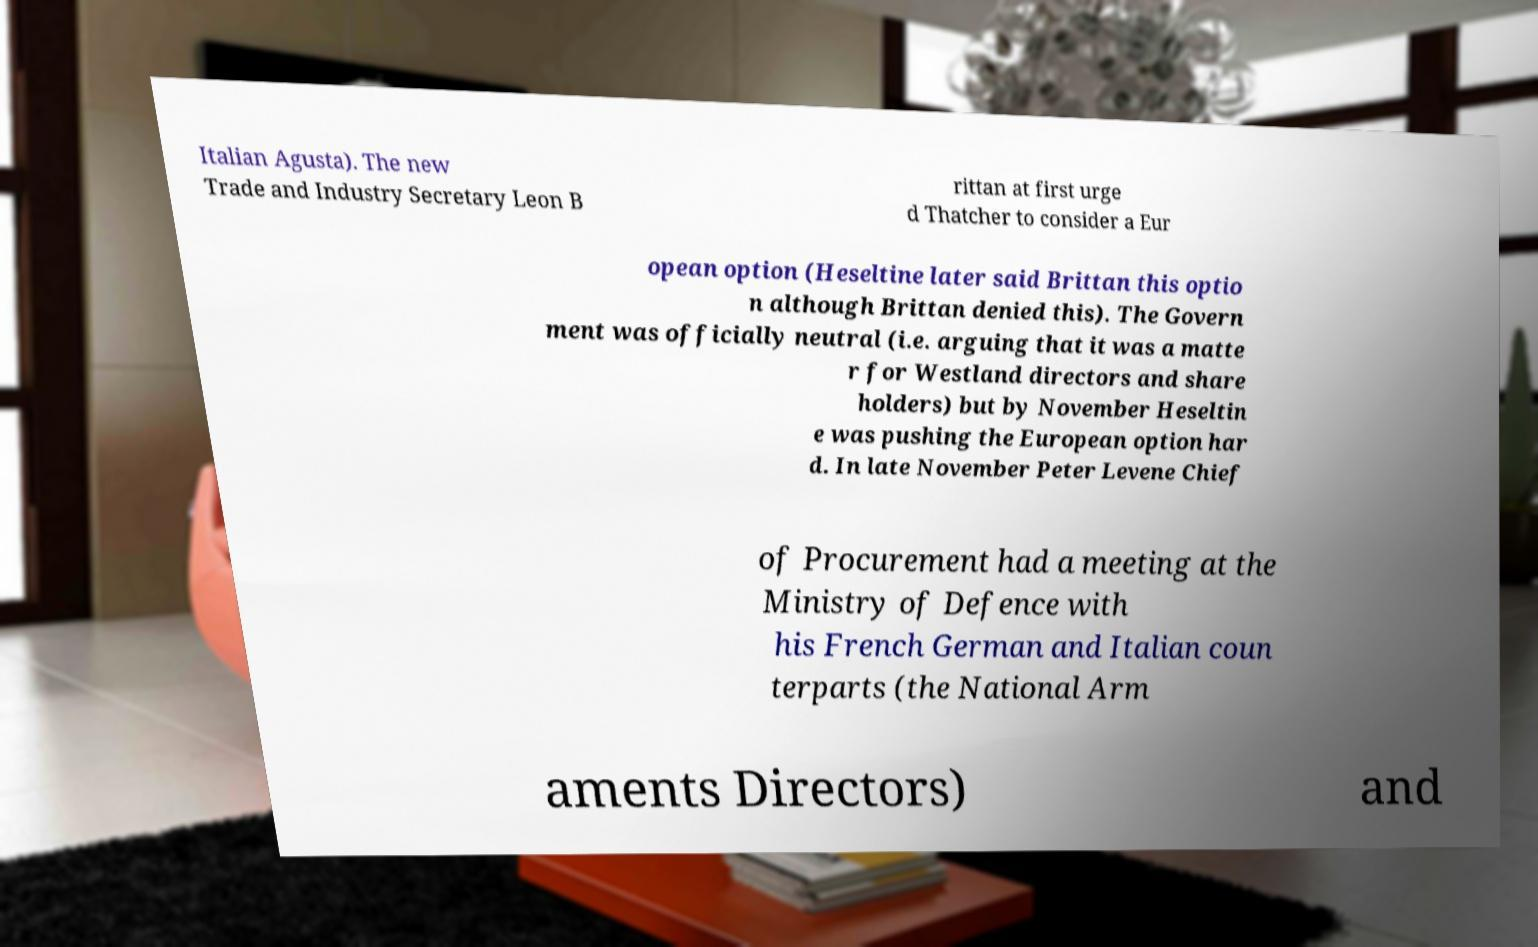For documentation purposes, I need the text within this image transcribed. Could you provide that? Italian Agusta). The new Trade and Industry Secretary Leon B rittan at first urge d Thatcher to consider a Eur opean option (Heseltine later said Brittan this optio n although Brittan denied this). The Govern ment was officially neutral (i.e. arguing that it was a matte r for Westland directors and share holders) but by November Heseltin e was pushing the European option har d. In late November Peter Levene Chief of Procurement had a meeting at the Ministry of Defence with his French German and Italian coun terparts (the National Arm aments Directors) and 